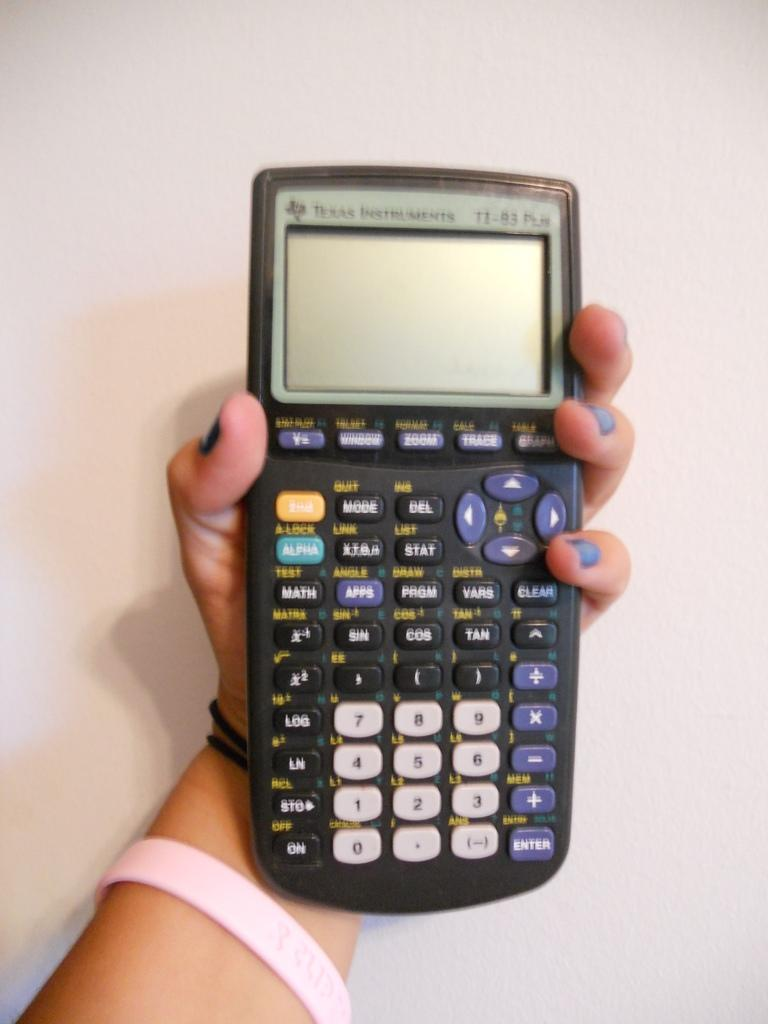Provide a one-sentence caption for the provided image. hand holding a texas instruments TI-83 graphing calculator. 